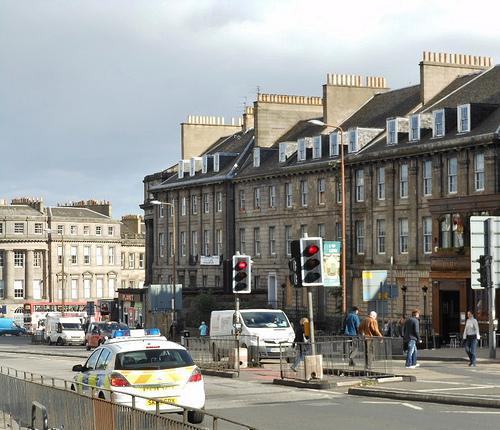Question: when was this taken?
Choices:
A. During the night.
B. During the day.
C. In the afternoon.
D. During the evening.
Answer with the letter. Answer: B Question: what color is most of the nearest car?
Choices:
A. Black.
B. Blue.
C. White.
D. Red.
Answer with the letter. Answer: C Question: who is crossing the walk way?
Choices:
A. The people.
B. Policeman.
C. Children.
D. The busdriver.
Answer with the letter. Answer: A Question: how is the sky?
Choices:
A. Rainy.
B. Overcast.
C. Dark.
D. Cloudy.
Answer with the letter. Answer: D 